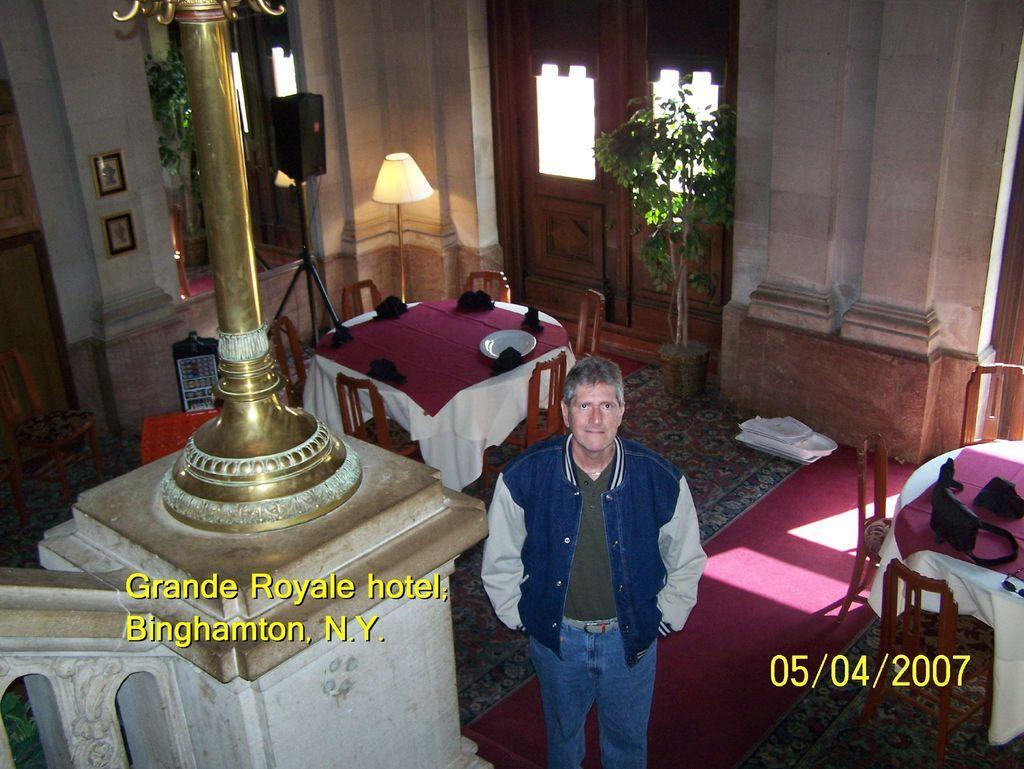Describe this image in one or two sentences. In this image i can see a man standing at left i can see a pole at the back ground i can see a dining table, plate a cloth on the table, a small plant, lamp, a door and a wall. 